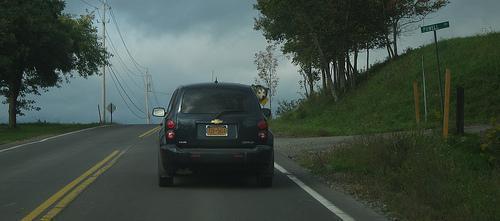How many cars are on the road?
Give a very brief answer. 1. 